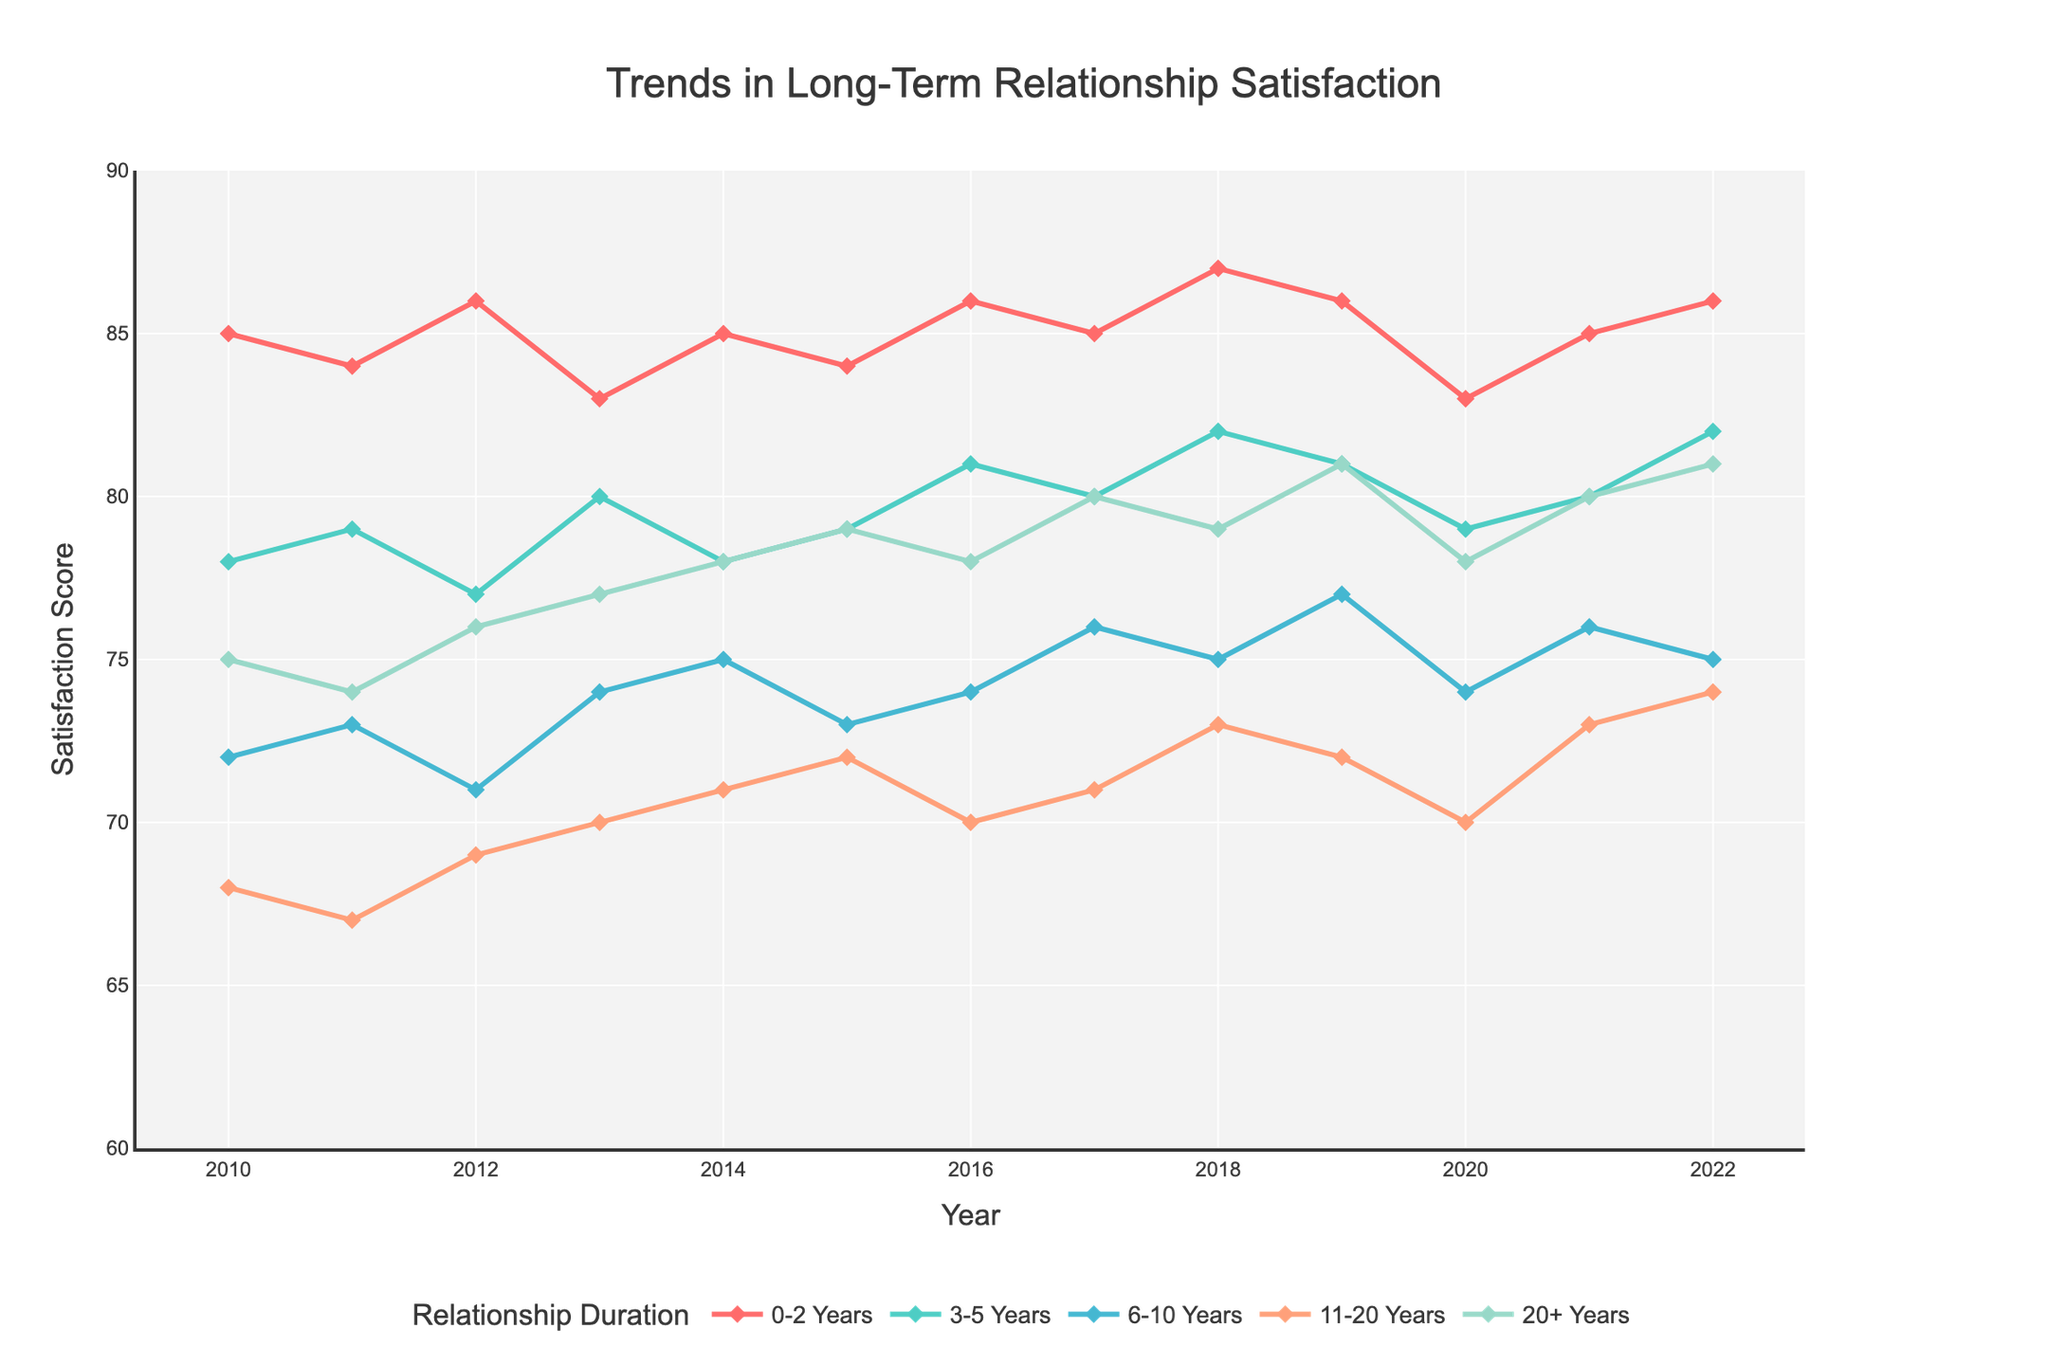Which year shows the highest satisfaction for relationships lasting 0-2 years? Look for the highest point on the line corresponding to 0-2 years. The highest point appears in 2018 with a score of 87.
Answer: 2018 Which category saw a decreasing trend overall from 2010 to 2022? Examine each line for an overall decrease from left to right. The 11-20 Years category shows a decrease from 68 in 2010 to 74 in 2022.
Answer: 11-20 Years Compare the satisfaction levels in 2020 for the categories 0-2 Years and 20+ Years. Which one has a higher value? Look at the values for 2020 on the lines for 0-2 Years and 20+ Years. 0-2 Years has 83, and 20+ Years has 78.
Answer: 0-2 Years Between which years did the category 6-10 Years experience its highest increase in satisfaction? Identify the two consecutive years with the largest jump for 6-10 Years. This occurs between 2016 (74) and 2017 (76).
Answer: 2016 to 2017 What is the average satisfaction score for the category 3-5 Years over the entire period? Sum the values for 3-5 Years across all years and divide by the number of years (13). The values are 78, 79, 77, 80, 78, 79, 81, 80, 82, 81, 79, 80, and 82. The sum is 936, and the average is 936/13 ≈ 72.
Answer: ≈ 72 In which year did the satisfaction level for relationships lasting more than 20 years surpass those lasting 0-2 years? Compare year by year when 20+ Years value exceeds 0-2 Years value. In 2020, 20+ Years (78) surpasses 0-2 Years (83).
Answer: 2020 For relationships lasting 0-2 years, what is the overall trend from 2010 to 2022? Analyze the general direction of the line for 0-2 Years. Although there are fluctuations, the overall trend is slightly positive, ending higher (86) than it started (85).
Answer: Increasing Which relationship duration category had the most stable trend (least fluctuations) during 2010-2022? Examine the lines for the smoothness and less variation. The 20+ Years category appears most stable, with a relatively even trend.
Answer: 20+ Years What is the difference in satisfaction scores between the highest and lowest points for the category 11-20 Years? Find the highest (74 in 2022) and lowest (67 in 2011) points for 11-20 Years. The difference is 74 - 67 = 7.
Answer: 7 